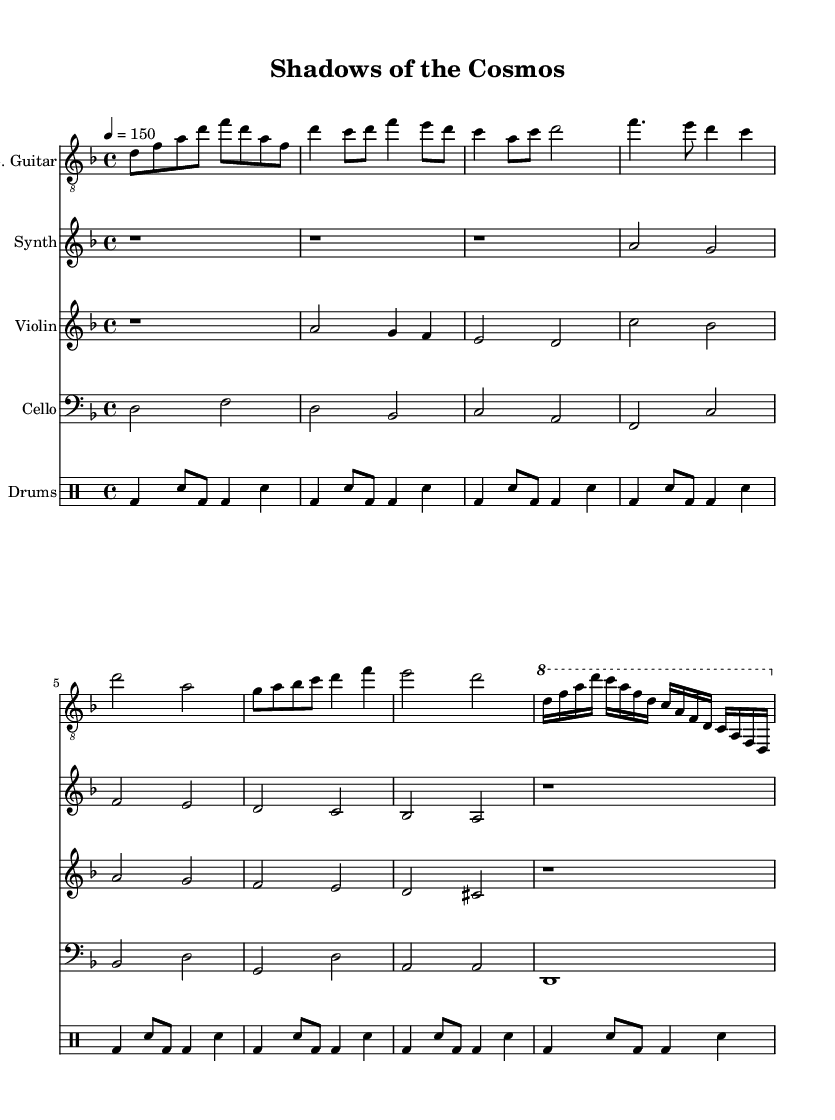What is the key signature of this music? The key signature is D minor, which is indicated at the beginning of the score by the presence of one flat (B♭).
Answer: D minor What is the time signature of this music? The time signature is 4/4, as noted at the start of the score, indicating four beats per measure.
Answer: 4/4 What is the tempo marking for this music? The tempo marking is 150 beats per minute, specified in the score with the instruction "4 = 150".
Answer: 150 How many bars are in the chorus section? The chorus consists of two bars, as indicated by the measures marked by the notes following the verse section.
Answer: 2 What instruments are featured in this composition? The score includes electric guitar, synth, violin, cello, and drums, as shown by the different staves for each instrument.
Answer: Electric guitar, synth, violin, cello, drums Which instrument plays the solo section? The solo section is performed by the electric guitar, as indicated by the notation presented within its dedicated staff.
Answer: Electric guitar What overall mood might this music convey based on its name and structure? The title "Shadows of the Cosmos" and the use of minor key, rhythmic intensity, and orchestration suggest a dark, mystical atmosphere, typical of symphonic metal themes.
Answer: Dark, mystical 